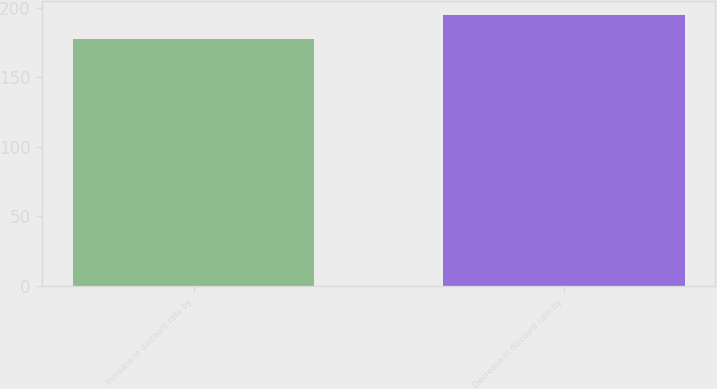<chart> <loc_0><loc_0><loc_500><loc_500><bar_chart><fcel>Increase in discount rate by<fcel>Decrease in discount rate by<nl><fcel>178<fcel>195<nl></chart> 